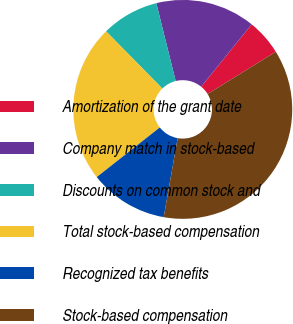Convert chart to OTSL. <chart><loc_0><loc_0><loc_500><loc_500><pie_chart><fcel>Amortization of the grant date<fcel>Company match in stock-based<fcel>Discounts on common stock and<fcel>Total stock-based compensation<fcel>Recognized tax benefits<fcel>Stock-based compensation<nl><fcel>5.34%<fcel>14.72%<fcel>8.47%<fcel>23.25%<fcel>11.6%<fcel>36.61%<nl></chart> 